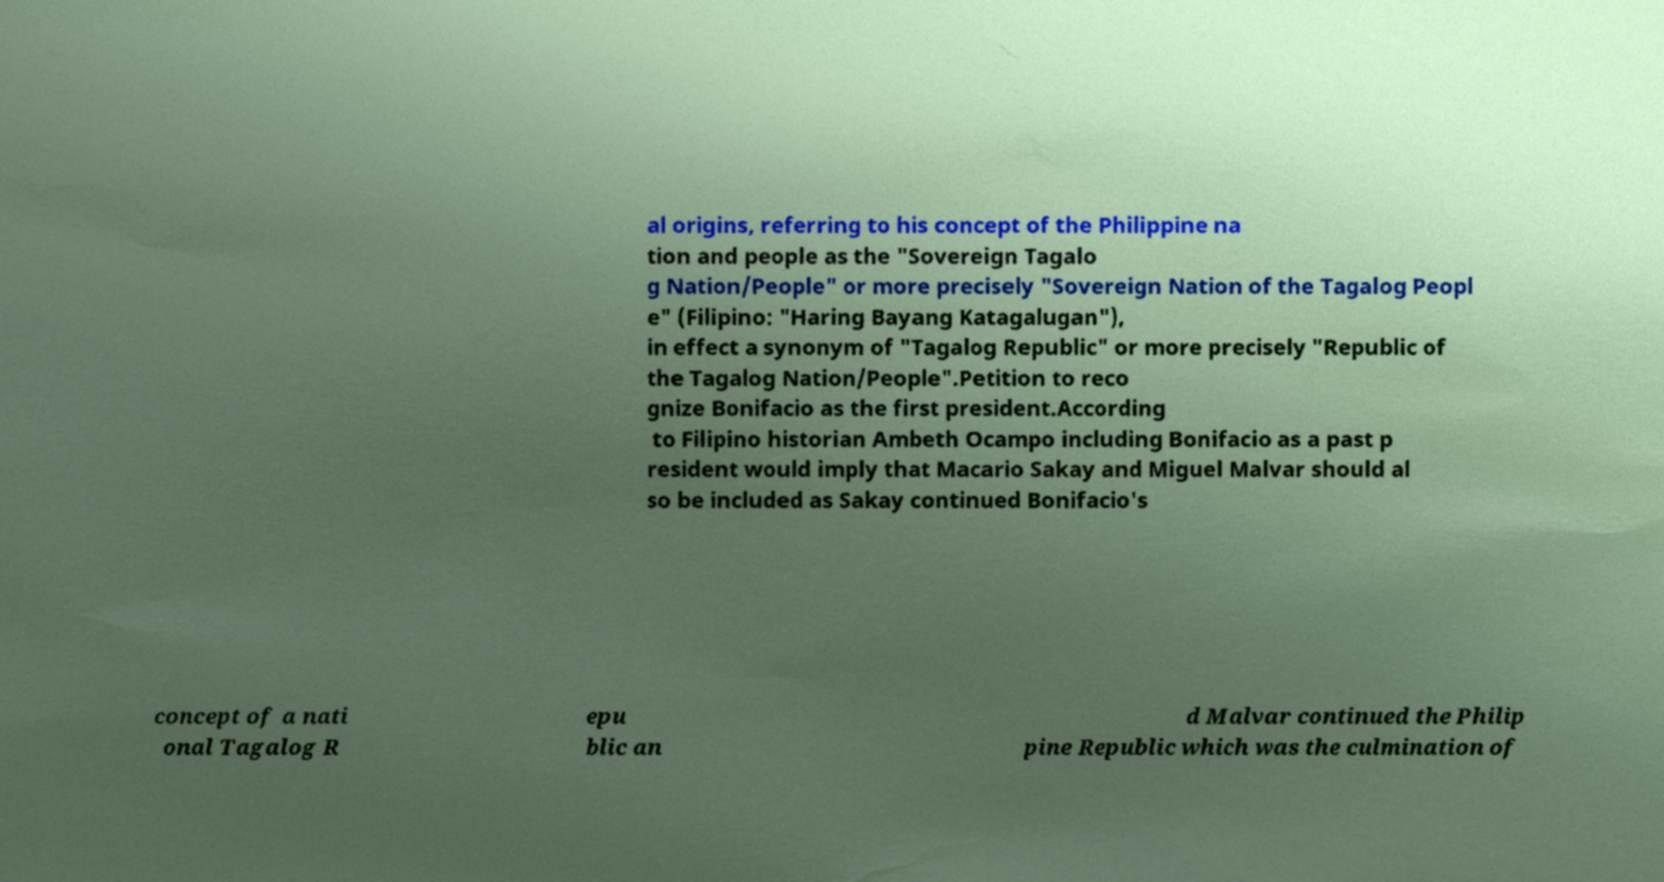Please identify and transcribe the text found in this image. al origins, referring to his concept of the Philippine na tion and people as the "Sovereign Tagalo g Nation/People" or more precisely "Sovereign Nation of the Tagalog Peopl e" (Filipino: "Haring Bayang Katagalugan"), in effect a synonym of "Tagalog Republic" or more precisely "Republic of the Tagalog Nation/People".Petition to reco gnize Bonifacio as the first president.According to Filipino historian Ambeth Ocampo including Bonifacio as a past p resident would imply that Macario Sakay and Miguel Malvar should al so be included as Sakay continued Bonifacio's concept of a nati onal Tagalog R epu blic an d Malvar continued the Philip pine Republic which was the culmination of 